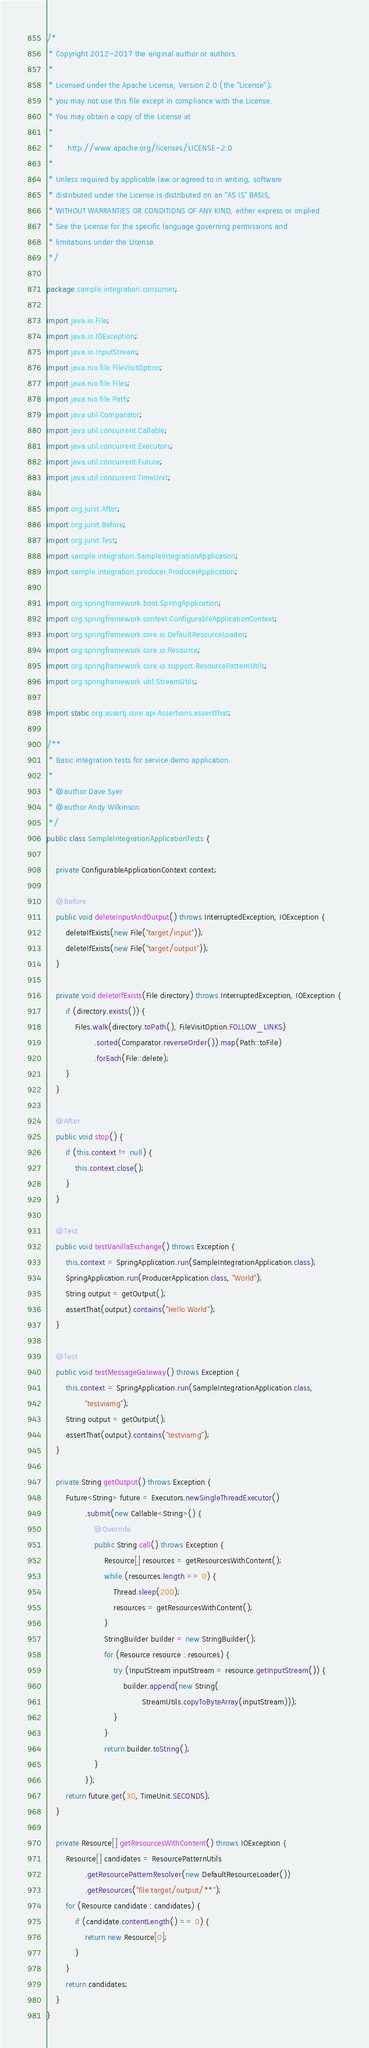Convert code to text. <code><loc_0><loc_0><loc_500><loc_500><_Java_>/*
 * Copyright 2012-2017 the original author or authors.
 *
 * Licensed under the Apache License, Version 2.0 (the "License");
 * you may not use this file except in compliance with the License.
 * You may obtain a copy of the License at
 *
 *      http://www.apache.org/licenses/LICENSE-2.0
 *
 * Unless required by applicable law or agreed to in writing, software
 * distributed under the License is distributed on an "AS IS" BASIS,
 * WITHOUT WARRANTIES OR CONDITIONS OF ANY KIND, either express or implied.
 * See the License for the specific language governing permissions and
 * limitations under the License.
 */

package sample.integration.consumer;

import java.io.File;
import java.io.IOException;
import java.io.InputStream;
import java.nio.file.FileVisitOption;
import java.nio.file.Files;
import java.nio.file.Path;
import java.util.Comparator;
import java.util.concurrent.Callable;
import java.util.concurrent.Executors;
import java.util.concurrent.Future;
import java.util.concurrent.TimeUnit;

import org.junit.After;
import org.junit.Before;
import org.junit.Test;
import sample.integration.SampleIntegrationApplication;
import sample.integration.producer.ProducerApplication;

import org.springframework.boot.SpringApplication;
import org.springframework.context.ConfigurableApplicationContext;
import org.springframework.core.io.DefaultResourceLoader;
import org.springframework.core.io.Resource;
import org.springframework.core.io.support.ResourcePatternUtils;
import org.springframework.util.StreamUtils;

import static org.assertj.core.api.Assertions.assertThat;

/**
 * Basic integration tests for service demo application.
 *
 * @author Dave Syer
 * @author Andy Wilkinson
 */
public class SampleIntegrationApplicationTests {

	private ConfigurableApplicationContext context;

	@Before
	public void deleteInputAndOutput() throws InterruptedException, IOException {
		deleteIfExists(new File("target/input"));
		deleteIfExists(new File("target/output"));
	}

	private void deleteIfExists(File directory) throws InterruptedException, IOException {
		if (directory.exists()) {
			Files.walk(directory.toPath(), FileVisitOption.FOLLOW_LINKS)
					.sorted(Comparator.reverseOrder()).map(Path::toFile)
					.forEach(File::delete);
		}
	}

	@After
	public void stop() {
		if (this.context != null) {
			this.context.close();
		}
	}

	@Test
	public void testVanillaExchange() throws Exception {
		this.context = SpringApplication.run(SampleIntegrationApplication.class);
		SpringApplication.run(ProducerApplication.class, "World");
		String output = getOutput();
		assertThat(output).contains("Hello World");
	}

	@Test
	public void testMessageGateway() throws Exception {
		this.context = SpringApplication.run(SampleIntegrationApplication.class,
				"testviamg");
		String output = getOutput();
		assertThat(output).contains("testviamg");
	}

	private String getOutput() throws Exception {
		Future<String> future = Executors.newSingleThreadExecutor()
				.submit(new Callable<String>() {
					@Override
					public String call() throws Exception {
						Resource[] resources = getResourcesWithContent();
						while (resources.length == 0) {
							Thread.sleep(200);
							resources = getResourcesWithContent();
						}
						StringBuilder builder = new StringBuilder();
						for (Resource resource : resources) {
							try (InputStream inputStream = resource.getInputStream()) {
								builder.append(new String(
										StreamUtils.copyToByteArray(inputStream)));
							}
						}
						return builder.toString();
					}
				});
		return future.get(30, TimeUnit.SECONDS);
	}

	private Resource[] getResourcesWithContent() throws IOException {
		Resource[] candidates = ResourcePatternUtils
				.getResourcePatternResolver(new DefaultResourceLoader())
				.getResources("file:target/output/**");
		for (Resource candidate : candidates) {
			if (candidate.contentLength() == 0) {
				return new Resource[0];
			}
		}
		return candidates;
	}
}
</code> 